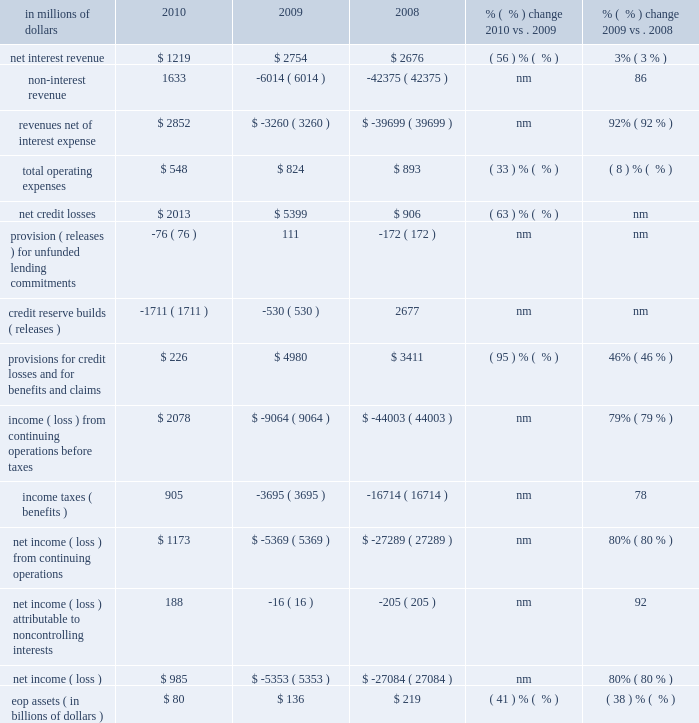Special asset pool special asset pool ( sap ) , which constituted approximately 22% ( 22 % ) of citi holdings by assets as of december 31 , 2010 , is a portfolio of securities , loans and other assets that citigroup intends to actively reduce over time through asset sales and portfolio run-off .
At december 31 , 2010 , sap had $ 80 billion of assets .
Sap assets have declined by $ 248 billion , or 76% ( 76 % ) , from peak levels in 2007 reflecting cumulative write-downs , asset sales and portfolio run-off .
In millions of dollars 2010 2009 2008 % (  % ) change 2010 vs .
2009 % (  % ) change 2009 vs .
2008 .
Nm not meaningful 2010 vs .
2009 revenues , net of interest expense increased $ 6.1 billion , primarily due to the improvement of revenue marks in 2010 .
Aggregate marks were negative $ 2.6 billion in 2009 as compared to positive marks of $ 3.4 billion in 2010 ( see 201citems impacting sap revenues 201d below ) .
Revenue in the current year included positive marks of $ 2.0 billion related to sub-prime related direct exposure , a positive $ 0.5 billion cva related to the monoline insurers , and $ 0.4 billion on private equity positions .
These positive marks were partially offset by negative revenues of $ 0.5 billion on alt-a mortgages and $ 0.4 billion on commercial real estate .
Operating expenses decreased 33% ( 33 % ) in 2010 , mainly driven by the absence of the u.s .
Government loss-sharing agreement , lower compensation , and lower transaction expenses .
Provisions for credit losses and for benefits and claims decreased $ 4.8 billion due to a decrease in net credit losses of $ 3.4 billion and a higher release of loan loss reserves and unfunded lending commitments of $ 1.4 billion .
Assets declined 41% ( 41 % ) from the prior year , primarily driven by sales and amortization and prepayments .
Asset sales of $ 39 billion for the year of 2010 generated pretax gains of approximately $ 1.3 billion .
2009 vs .
2008 revenues , net of interest expense increased $ 36.4 billion in 2009 , primarily due to the absence of significant negative revenue marks occurring in the prior year .
Total negative marks were $ 2.6 billion in 2009 as compared to $ 37.4 billion in 2008 .
Revenue in 2009 included positive marks of $ 0.8 billion on subprime-related direct exposures .
These positive revenues were partially offset by negative revenues of $ 1.5 billion on alt-a mortgages , $ 0.8 billion of write-downs on commercial real estate , and a negative $ 1.6 billion cva on the monoline insurers and fair value option liabilities .
Revenue was also affected by negative marks on private equity positions and write-downs on highly leveraged finance commitments .
Operating expenses decreased 8% ( 8 % ) in 2009 , mainly driven by lower compensation and lower volumes and transaction expenses , partially offset by costs associated with the u.s .
Government loss-sharing agreement exited in the fourth quarter of 2009 .
Provisions for credit losses and for benefits and claims increased $ 1.6 billion , primarily driven by $ 4.5 billion in increased net credit losses , partially offset by a lower provision for loan losses and unfunded lending commitments of $ 2.9 billion .
Assets declined 38% ( 38 % ) versus the prior year , primarily driven by amortization and prepayments , sales , marks and charge-offs. .
What percentage of revenue net of interest expense is due to net interest revenue in 2010? 
Computations: (1219 / 2852)
Answer: 0.42742. 